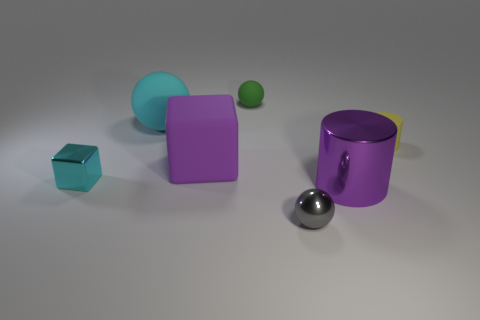There is a gray ball that is the same size as the yellow thing; what material is it?
Provide a short and direct response. Metal. Do the purple thing on the left side of the green ball and the tiny matte cylinder have the same size?
Your response must be concise. No. How many balls are either red matte things or big purple rubber objects?
Your response must be concise. 0. What material is the cyan object that is in front of the big sphere?
Offer a terse response. Metal. Is the number of cyan cubes less than the number of small yellow rubber spheres?
Your response must be concise. No. How big is the matte thing that is to the left of the green object and in front of the big cyan matte thing?
Your answer should be compact. Large. What size is the sphere that is in front of the metallic object that is to the right of the thing in front of the big metallic object?
Provide a succinct answer. Small. What number of other things are there of the same color as the large rubber block?
Your response must be concise. 1. There is a tiny metallic thing that is on the left side of the green object; does it have the same color as the tiny metallic ball?
Offer a very short reply. No. What number of things are yellow objects or small green objects?
Offer a very short reply. 2. 